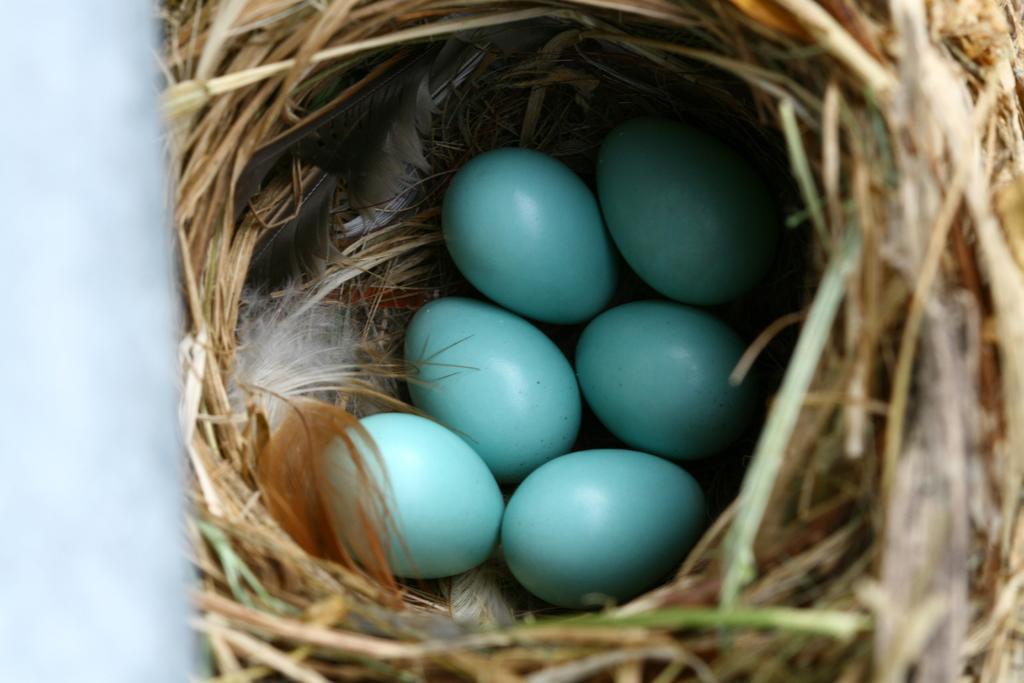How would you summarize this image in a sentence or two? In this picture we can see six eggs in a nest. Those are in blue color. 